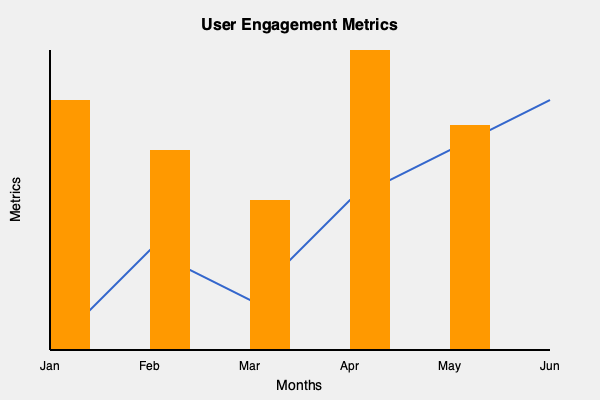As an app developer for outdoor expedition bookings, you're analyzing user engagement metrics over a 6-month period. The line graph represents the average time spent on the app per session, while the bar chart shows the number of expeditions booked each month. What insights can you draw about user behavior and potential areas for improvement in your app based on these metrics? To analyze the user engagement metrics and draw insights, let's break down the information presented in the graph:

1. Time spent on app (line graph):
   - Shows an overall increasing trend from January to June
   - Slight dip in March, but recovers and continues to rise

2. Number of expeditions booked (bar chart):
   - Fluctuates month to month
   - Highest in April, lowest in March
   - No clear correlation with time spent on app

3. Relationship between metrics:
   - Time spent on app increases steadily, but bookings don't follow the same pattern
   - In March, both metrics show a decline
   - April shows the highest number of bookings, but not the highest time spent

Insights and potential improvements:

1. Increasing engagement: The steady increase in time spent on the app suggests that users are finding more value or content to explore over time. This is positive, but there's room to convert this engagement into more bookings.

2. March dip: Both metrics declined in March. This could be due to seasonal factors, technical issues, or a lack of attractive expedition options. Investigate the cause and plan for mitigation in future years.

3. Conversion optimization: Despite increased time spent on the app, bookings aren't consistently increasing. This suggests a need to optimize the booking process or provide more compelling expedition options to convert engagement into sales.

4. April peak: Analyze what made April successful in terms of bookings. Was it due to specific promotions, new expedition offerings, or seasonal trends? Use these insights to replicate success in other months.

5. User journey analysis: Investigate why users spend more time on the app but don't always book. Are they comparison shopping, lacking decision-making information, or encountering barriers in the booking process?

6. Content strategy: Consider adding more engaging content related to popular expeditions or destinations to maintain the upward trend in time spent on the app.

7. Personalization: Implement personalized recommendations based on user behavior to increase the likelihood of booking while users spend time on the app.

8. Seasonal planning: Use the data to plan marketing efforts, promotions, and expedition offerings according to observed seasonal trends.
Answer: Increase in app engagement doesn't correlate with consistent booking growth; optimize conversion, analyze successful months, improve user journey, and implement personalized recommendations. 